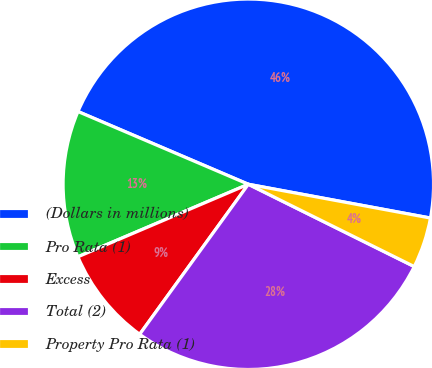Convert chart. <chart><loc_0><loc_0><loc_500><loc_500><pie_chart><fcel>(Dollars in millions)<fcel>Pro Rata (1)<fcel>Excess<fcel>Total (2)<fcel>Property Pro Rata (1)<nl><fcel>46.5%<fcel>12.83%<fcel>8.62%<fcel>27.65%<fcel>4.41%<nl></chart> 